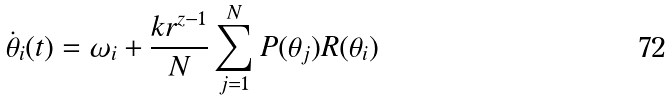Convert formula to latex. <formula><loc_0><loc_0><loc_500><loc_500>\dot { \theta } _ { i } ( t ) = \omega _ { i } + \frac { k r ^ { z - 1 } } N \sum _ { j = 1 } ^ { N } P ( \theta _ { j } ) R ( \theta _ { i } )</formula> 